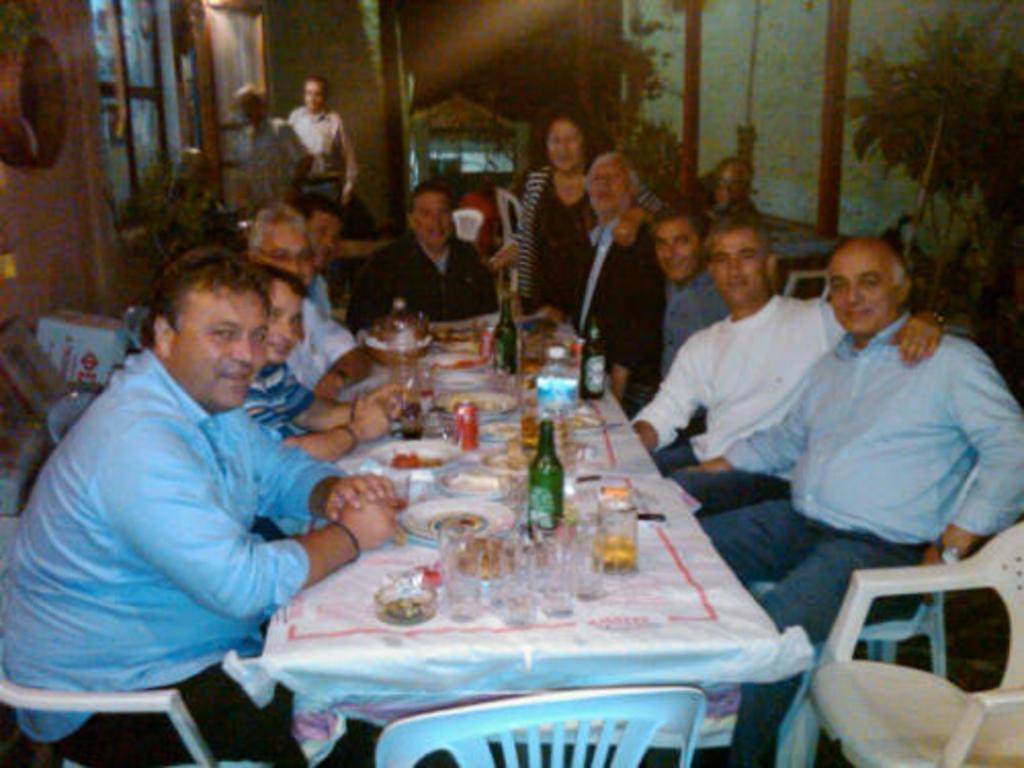How would you summarize this image in a sentence or two? In this picture we can see a group of people who are sitting on a chair and having a food. Here we can see two persons standing on the top left. 